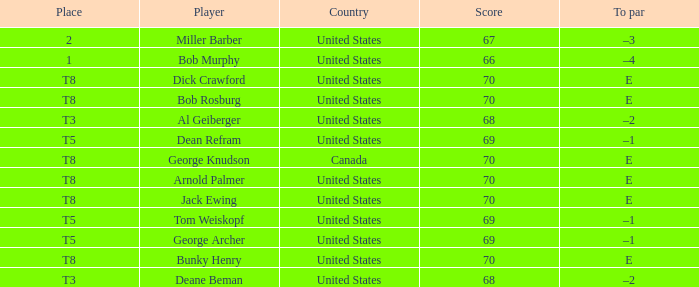Where did Bob Murphy of the United States place? 1.0. 